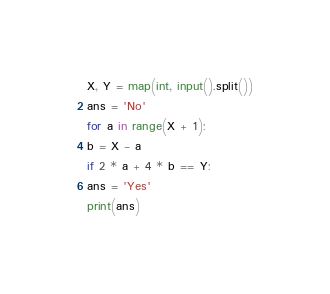Convert code to text. <code><loc_0><loc_0><loc_500><loc_500><_Python_>X, Y = map(int, input().split())
ans = 'No'
for a in range(X + 1):
b = X - a
if 2 * a + 4 * b == Y:
ans = 'Yes'
print(ans)</code> 